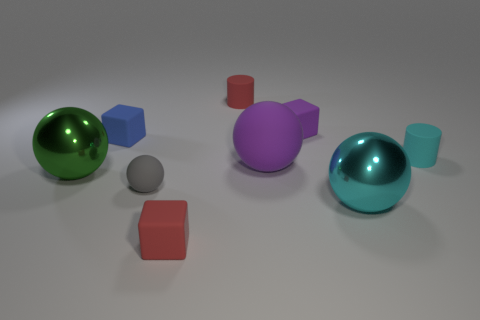Subtract all green balls. How many balls are left? 3 Subtract all purple balls. How many balls are left? 3 Add 1 green objects. How many objects exist? 10 Subtract all cubes. How many objects are left? 6 Subtract all blue cubes. Subtract all gray spheres. How many cubes are left? 2 Add 3 blue shiny things. How many blue shiny things exist? 3 Subtract 1 purple cubes. How many objects are left? 8 Subtract 1 blocks. How many blocks are left? 2 Subtract all large shiny balls. Subtract all green shiny balls. How many objects are left? 6 Add 1 cyan balls. How many cyan balls are left? 2 